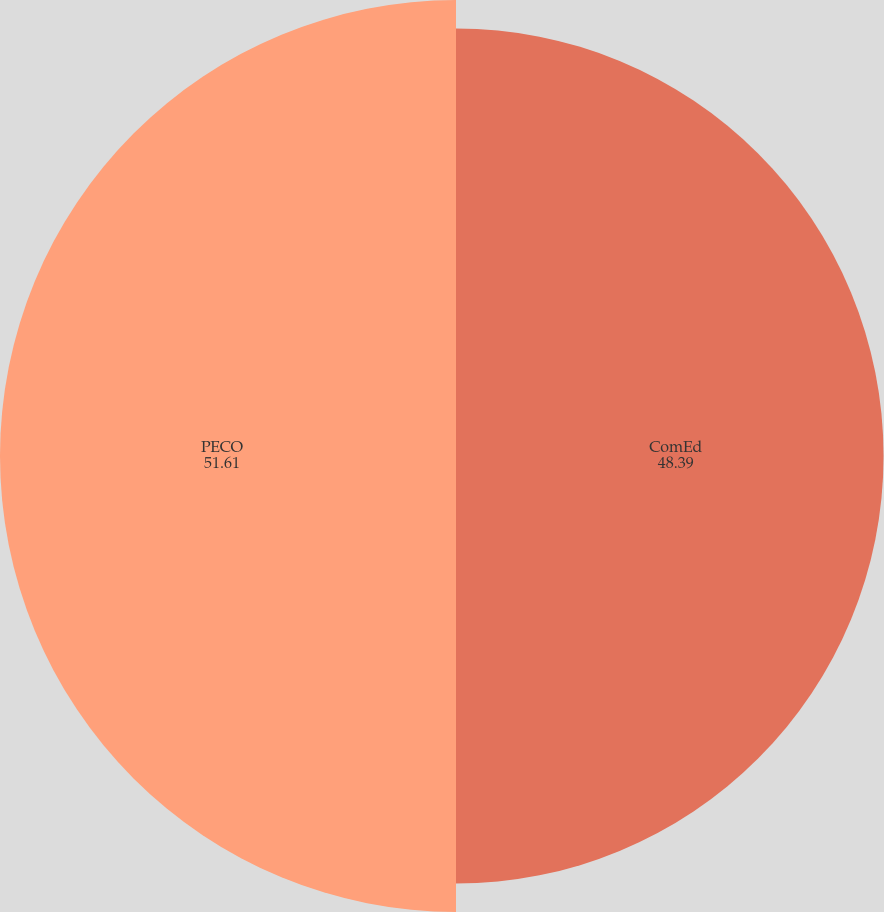Convert chart to OTSL. <chart><loc_0><loc_0><loc_500><loc_500><pie_chart><fcel>ComEd<fcel>PECO<nl><fcel>48.39%<fcel>51.61%<nl></chart> 